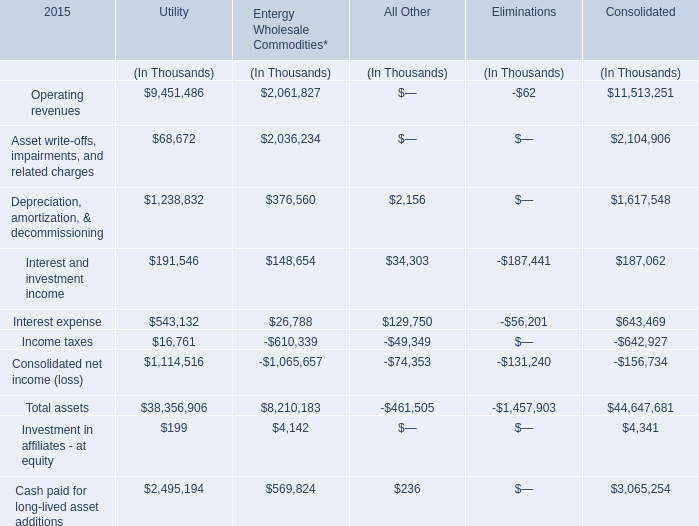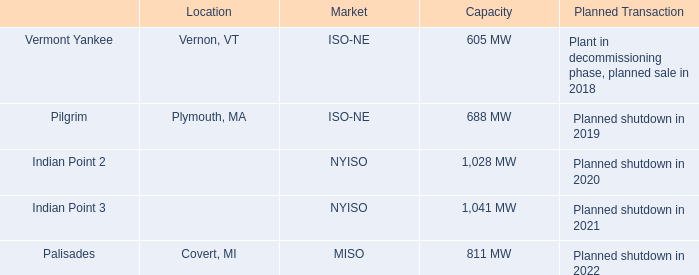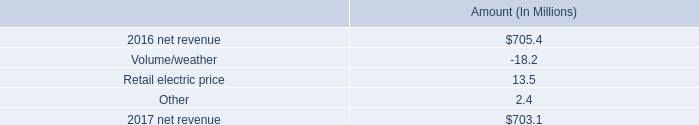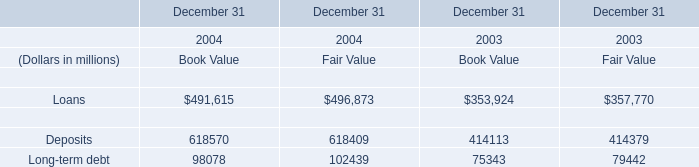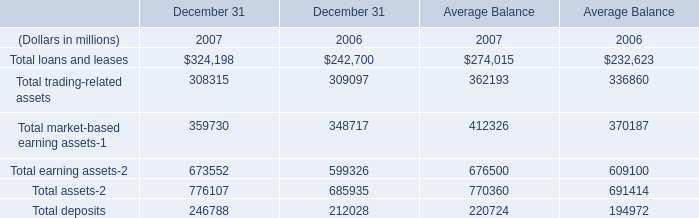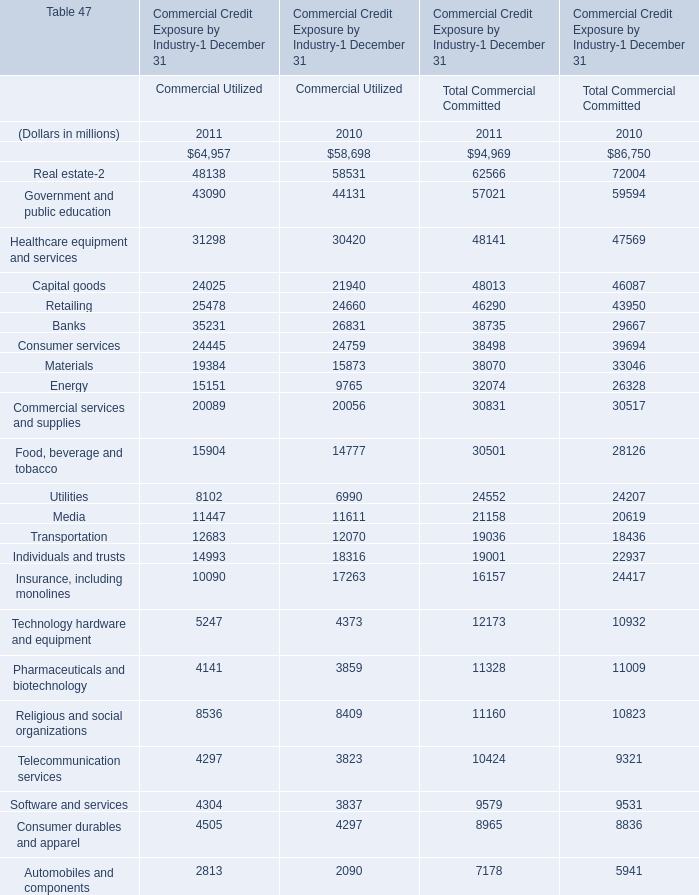In what year is Investment in affiliates - at equity greater than 100? 
Answer: 2015. 